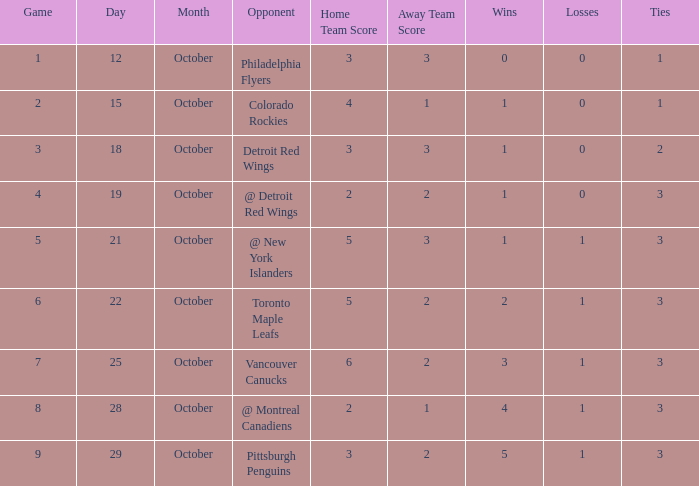Name the least game for october 21 5.0. 